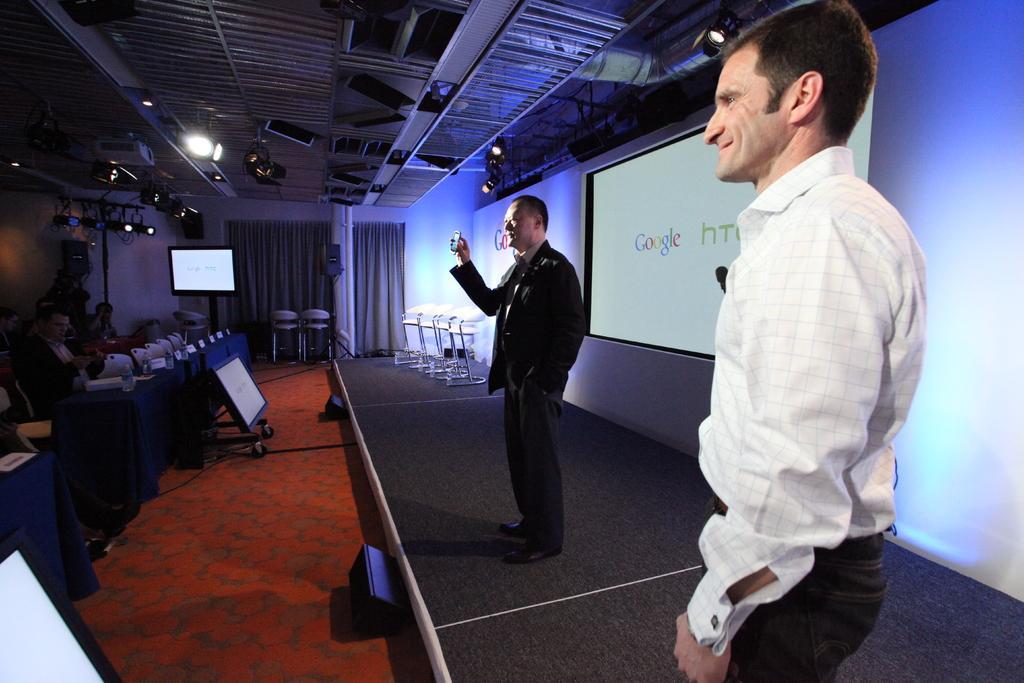In one or two sentences, can you explain what this image depicts? Few persons are sitting,these two persons are standing and this person holding mobile. On the background we can see wall,screen. On the top we can see lights. We can see tables,televisions on the floor. 